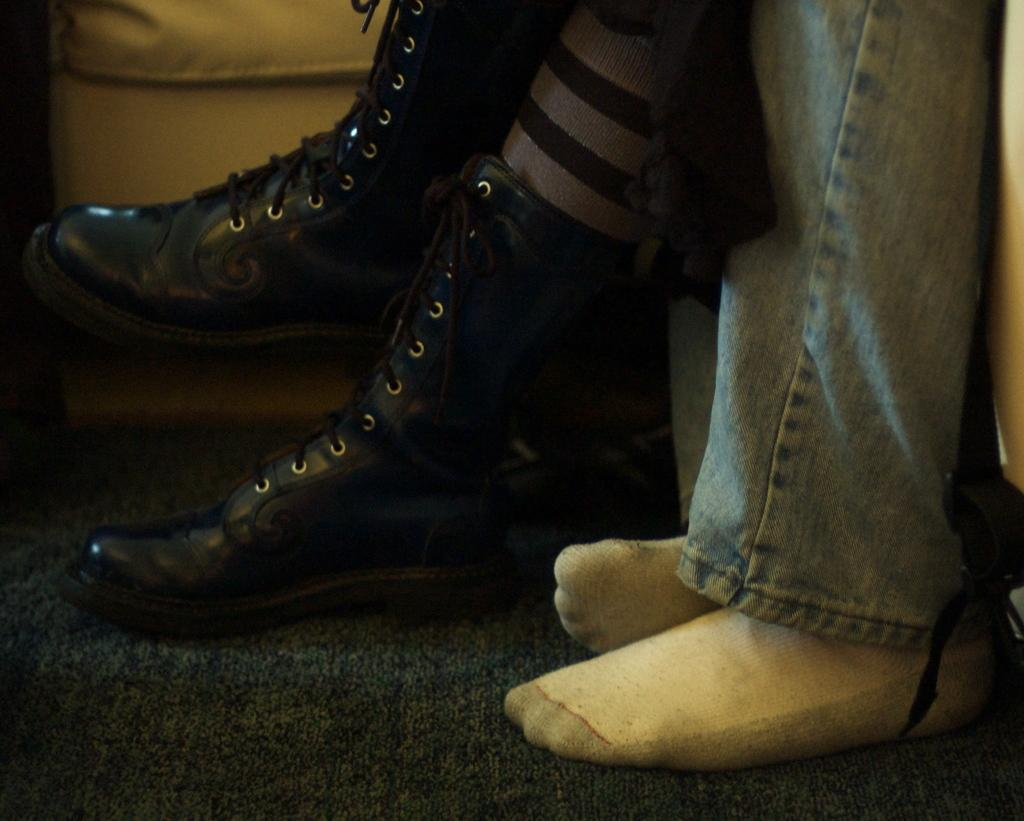How many people are present in the image based on the visible legs? There are two persons in the image based on the visible legs. What can be inferred about the person wearing shoes? One person is wearing shoes in the image. What is located at the bottom of the image? There is a mat at the bottom of the image. What type of attraction can be seen in the background of the image? There is no background or attraction visible in the image; it only shows legs and a mat. Is there a brush visible in the image? No, there is no brush present in the image. 